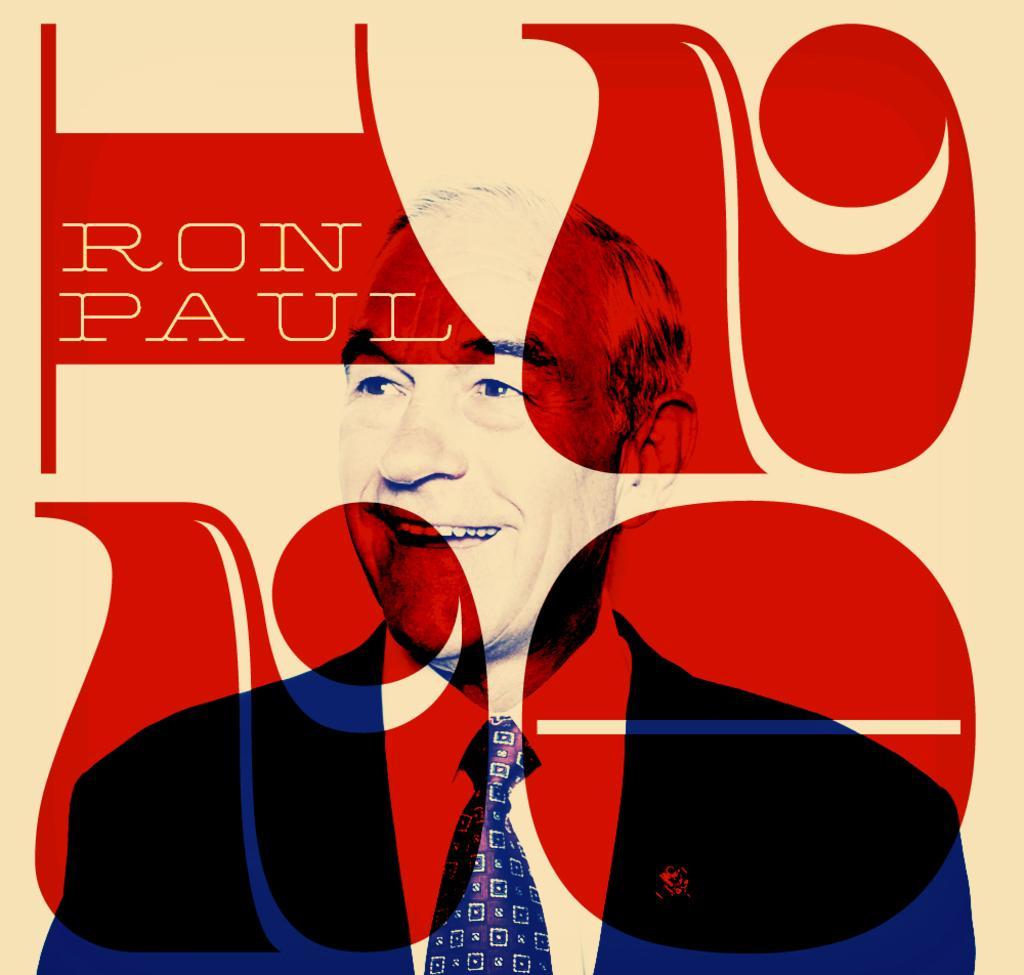Please provide a concise description of this image. In the image there is a man smiling. And there is something written on it. And also there are some designs. 